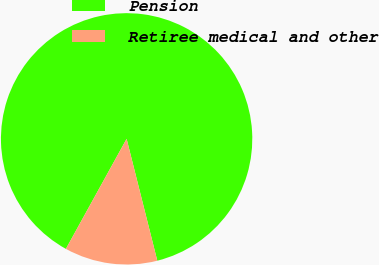<chart> <loc_0><loc_0><loc_500><loc_500><pie_chart><fcel>Pension<fcel>Retiree medical and other<nl><fcel>88.05%<fcel>11.95%<nl></chart> 